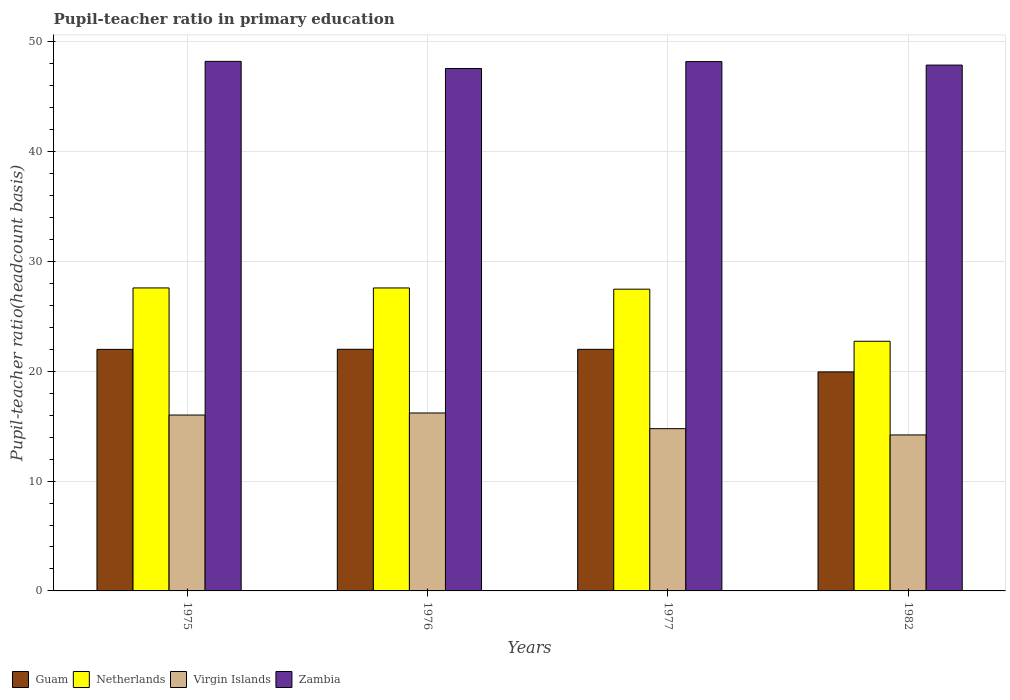How many different coloured bars are there?
Make the answer very short. 4. How many bars are there on the 1st tick from the left?
Keep it short and to the point. 4. In how many cases, is the number of bars for a given year not equal to the number of legend labels?
Your response must be concise. 0. What is the pupil-teacher ratio in primary education in Virgin Islands in 1976?
Ensure brevity in your answer.  16.2. Across all years, what is the maximum pupil-teacher ratio in primary education in Zambia?
Your response must be concise. 48.21. Across all years, what is the minimum pupil-teacher ratio in primary education in Zambia?
Your response must be concise. 47.56. In which year was the pupil-teacher ratio in primary education in Guam maximum?
Ensure brevity in your answer.  1976. What is the total pupil-teacher ratio in primary education in Zambia in the graph?
Ensure brevity in your answer.  191.83. What is the difference between the pupil-teacher ratio in primary education in Virgin Islands in 1975 and that in 1976?
Your answer should be compact. -0.19. What is the difference between the pupil-teacher ratio in primary education in Virgin Islands in 1982 and the pupil-teacher ratio in primary education in Netherlands in 1976?
Your answer should be compact. -13.38. What is the average pupil-teacher ratio in primary education in Virgin Islands per year?
Provide a succinct answer. 15.3. In the year 1975, what is the difference between the pupil-teacher ratio in primary education in Guam and pupil-teacher ratio in primary education in Netherlands?
Your answer should be very brief. -5.59. What is the ratio of the pupil-teacher ratio in primary education in Guam in 1975 to that in 1976?
Provide a short and direct response. 1. Is the difference between the pupil-teacher ratio in primary education in Guam in 1977 and 1982 greater than the difference between the pupil-teacher ratio in primary education in Netherlands in 1977 and 1982?
Make the answer very short. No. What is the difference between the highest and the second highest pupil-teacher ratio in primary education in Virgin Islands?
Keep it short and to the point. 0.19. What is the difference between the highest and the lowest pupil-teacher ratio in primary education in Netherlands?
Keep it short and to the point. 4.86. Is it the case that in every year, the sum of the pupil-teacher ratio in primary education in Netherlands and pupil-teacher ratio in primary education in Virgin Islands is greater than the sum of pupil-teacher ratio in primary education in Zambia and pupil-teacher ratio in primary education in Guam?
Provide a succinct answer. No. What does the 2nd bar from the right in 1977 represents?
Ensure brevity in your answer.  Virgin Islands. Is it the case that in every year, the sum of the pupil-teacher ratio in primary education in Guam and pupil-teacher ratio in primary education in Netherlands is greater than the pupil-teacher ratio in primary education in Virgin Islands?
Offer a very short reply. Yes. Are all the bars in the graph horizontal?
Offer a very short reply. No. How many years are there in the graph?
Keep it short and to the point. 4. What is the difference between two consecutive major ticks on the Y-axis?
Your answer should be compact. 10. Are the values on the major ticks of Y-axis written in scientific E-notation?
Your answer should be very brief. No. Does the graph contain grids?
Keep it short and to the point. Yes. How many legend labels are there?
Offer a very short reply. 4. How are the legend labels stacked?
Give a very brief answer. Horizontal. What is the title of the graph?
Your answer should be very brief. Pupil-teacher ratio in primary education. Does "Kazakhstan" appear as one of the legend labels in the graph?
Make the answer very short. No. What is the label or title of the X-axis?
Provide a succinct answer. Years. What is the label or title of the Y-axis?
Provide a succinct answer. Pupil-teacher ratio(headcount basis). What is the Pupil-teacher ratio(headcount basis) of Guam in 1975?
Your answer should be very brief. 21.99. What is the Pupil-teacher ratio(headcount basis) of Netherlands in 1975?
Keep it short and to the point. 27.58. What is the Pupil-teacher ratio(headcount basis) of Virgin Islands in 1975?
Provide a short and direct response. 16.01. What is the Pupil-teacher ratio(headcount basis) of Zambia in 1975?
Offer a terse response. 48.21. What is the Pupil-teacher ratio(headcount basis) of Guam in 1976?
Your answer should be compact. 22. What is the Pupil-teacher ratio(headcount basis) of Netherlands in 1976?
Your answer should be compact. 27.58. What is the Pupil-teacher ratio(headcount basis) of Virgin Islands in 1976?
Provide a short and direct response. 16.2. What is the Pupil-teacher ratio(headcount basis) in Zambia in 1976?
Offer a terse response. 47.56. What is the Pupil-teacher ratio(headcount basis) in Guam in 1977?
Your response must be concise. 21.99. What is the Pupil-teacher ratio(headcount basis) in Netherlands in 1977?
Provide a short and direct response. 27.47. What is the Pupil-teacher ratio(headcount basis) in Virgin Islands in 1977?
Your response must be concise. 14.77. What is the Pupil-teacher ratio(headcount basis) in Zambia in 1977?
Your answer should be compact. 48.19. What is the Pupil-teacher ratio(headcount basis) in Guam in 1982?
Make the answer very short. 19.94. What is the Pupil-teacher ratio(headcount basis) of Netherlands in 1982?
Provide a succinct answer. 22.73. What is the Pupil-teacher ratio(headcount basis) of Virgin Islands in 1982?
Give a very brief answer. 14.2. What is the Pupil-teacher ratio(headcount basis) in Zambia in 1982?
Ensure brevity in your answer.  47.87. Across all years, what is the maximum Pupil-teacher ratio(headcount basis) in Guam?
Keep it short and to the point. 22. Across all years, what is the maximum Pupil-teacher ratio(headcount basis) in Netherlands?
Ensure brevity in your answer.  27.58. Across all years, what is the maximum Pupil-teacher ratio(headcount basis) of Virgin Islands?
Make the answer very short. 16.2. Across all years, what is the maximum Pupil-teacher ratio(headcount basis) of Zambia?
Your response must be concise. 48.21. Across all years, what is the minimum Pupil-teacher ratio(headcount basis) of Guam?
Make the answer very short. 19.94. Across all years, what is the minimum Pupil-teacher ratio(headcount basis) in Netherlands?
Ensure brevity in your answer.  22.73. Across all years, what is the minimum Pupil-teacher ratio(headcount basis) in Zambia?
Keep it short and to the point. 47.56. What is the total Pupil-teacher ratio(headcount basis) of Guam in the graph?
Your answer should be very brief. 85.92. What is the total Pupil-teacher ratio(headcount basis) of Netherlands in the graph?
Offer a very short reply. 105.36. What is the total Pupil-teacher ratio(headcount basis) of Virgin Islands in the graph?
Provide a short and direct response. 61.18. What is the total Pupil-teacher ratio(headcount basis) of Zambia in the graph?
Provide a short and direct response. 191.83. What is the difference between the Pupil-teacher ratio(headcount basis) of Guam in 1975 and that in 1976?
Make the answer very short. -0.01. What is the difference between the Pupil-teacher ratio(headcount basis) in Netherlands in 1975 and that in 1976?
Offer a very short reply. 0. What is the difference between the Pupil-teacher ratio(headcount basis) in Virgin Islands in 1975 and that in 1976?
Offer a terse response. -0.19. What is the difference between the Pupil-teacher ratio(headcount basis) in Zambia in 1975 and that in 1976?
Keep it short and to the point. 0.65. What is the difference between the Pupil-teacher ratio(headcount basis) in Guam in 1975 and that in 1977?
Give a very brief answer. -0. What is the difference between the Pupil-teacher ratio(headcount basis) of Netherlands in 1975 and that in 1977?
Your answer should be very brief. 0.11. What is the difference between the Pupil-teacher ratio(headcount basis) of Virgin Islands in 1975 and that in 1977?
Make the answer very short. 1.24. What is the difference between the Pupil-teacher ratio(headcount basis) of Zambia in 1975 and that in 1977?
Your response must be concise. 0.02. What is the difference between the Pupil-teacher ratio(headcount basis) in Guam in 1975 and that in 1982?
Your response must be concise. 2.05. What is the difference between the Pupil-teacher ratio(headcount basis) in Netherlands in 1975 and that in 1982?
Offer a terse response. 4.86. What is the difference between the Pupil-teacher ratio(headcount basis) in Virgin Islands in 1975 and that in 1982?
Provide a succinct answer. 1.81. What is the difference between the Pupil-teacher ratio(headcount basis) in Zambia in 1975 and that in 1982?
Provide a succinct answer. 0.34. What is the difference between the Pupil-teacher ratio(headcount basis) of Guam in 1976 and that in 1977?
Your answer should be very brief. 0. What is the difference between the Pupil-teacher ratio(headcount basis) in Netherlands in 1976 and that in 1977?
Make the answer very short. 0.11. What is the difference between the Pupil-teacher ratio(headcount basis) of Virgin Islands in 1976 and that in 1977?
Offer a terse response. 1.43. What is the difference between the Pupil-teacher ratio(headcount basis) in Zambia in 1976 and that in 1977?
Ensure brevity in your answer.  -0.63. What is the difference between the Pupil-teacher ratio(headcount basis) of Guam in 1976 and that in 1982?
Your answer should be very brief. 2.06. What is the difference between the Pupil-teacher ratio(headcount basis) of Netherlands in 1976 and that in 1982?
Your answer should be very brief. 4.85. What is the difference between the Pupil-teacher ratio(headcount basis) of Virgin Islands in 1976 and that in 1982?
Your answer should be very brief. 2. What is the difference between the Pupil-teacher ratio(headcount basis) in Zambia in 1976 and that in 1982?
Your response must be concise. -0.31. What is the difference between the Pupil-teacher ratio(headcount basis) in Guam in 1977 and that in 1982?
Offer a terse response. 2.05. What is the difference between the Pupil-teacher ratio(headcount basis) of Netherlands in 1977 and that in 1982?
Give a very brief answer. 4.74. What is the difference between the Pupil-teacher ratio(headcount basis) in Virgin Islands in 1977 and that in 1982?
Make the answer very short. 0.57. What is the difference between the Pupil-teacher ratio(headcount basis) in Zambia in 1977 and that in 1982?
Offer a very short reply. 0.32. What is the difference between the Pupil-teacher ratio(headcount basis) in Guam in 1975 and the Pupil-teacher ratio(headcount basis) in Netherlands in 1976?
Offer a very short reply. -5.59. What is the difference between the Pupil-teacher ratio(headcount basis) in Guam in 1975 and the Pupil-teacher ratio(headcount basis) in Virgin Islands in 1976?
Give a very brief answer. 5.79. What is the difference between the Pupil-teacher ratio(headcount basis) of Guam in 1975 and the Pupil-teacher ratio(headcount basis) of Zambia in 1976?
Your answer should be very brief. -25.57. What is the difference between the Pupil-teacher ratio(headcount basis) in Netherlands in 1975 and the Pupil-teacher ratio(headcount basis) in Virgin Islands in 1976?
Your answer should be compact. 11.38. What is the difference between the Pupil-teacher ratio(headcount basis) of Netherlands in 1975 and the Pupil-teacher ratio(headcount basis) of Zambia in 1976?
Ensure brevity in your answer.  -19.98. What is the difference between the Pupil-teacher ratio(headcount basis) in Virgin Islands in 1975 and the Pupil-teacher ratio(headcount basis) in Zambia in 1976?
Provide a short and direct response. -31.55. What is the difference between the Pupil-teacher ratio(headcount basis) in Guam in 1975 and the Pupil-teacher ratio(headcount basis) in Netherlands in 1977?
Offer a terse response. -5.48. What is the difference between the Pupil-teacher ratio(headcount basis) in Guam in 1975 and the Pupil-teacher ratio(headcount basis) in Virgin Islands in 1977?
Provide a short and direct response. 7.22. What is the difference between the Pupil-teacher ratio(headcount basis) in Guam in 1975 and the Pupil-teacher ratio(headcount basis) in Zambia in 1977?
Offer a terse response. -26.2. What is the difference between the Pupil-teacher ratio(headcount basis) of Netherlands in 1975 and the Pupil-teacher ratio(headcount basis) of Virgin Islands in 1977?
Provide a short and direct response. 12.81. What is the difference between the Pupil-teacher ratio(headcount basis) of Netherlands in 1975 and the Pupil-teacher ratio(headcount basis) of Zambia in 1977?
Your answer should be very brief. -20.61. What is the difference between the Pupil-teacher ratio(headcount basis) of Virgin Islands in 1975 and the Pupil-teacher ratio(headcount basis) of Zambia in 1977?
Ensure brevity in your answer.  -32.18. What is the difference between the Pupil-teacher ratio(headcount basis) in Guam in 1975 and the Pupil-teacher ratio(headcount basis) in Netherlands in 1982?
Give a very brief answer. -0.74. What is the difference between the Pupil-teacher ratio(headcount basis) of Guam in 1975 and the Pupil-teacher ratio(headcount basis) of Virgin Islands in 1982?
Provide a short and direct response. 7.79. What is the difference between the Pupil-teacher ratio(headcount basis) of Guam in 1975 and the Pupil-teacher ratio(headcount basis) of Zambia in 1982?
Your response must be concise. -25.88. What is the difference between the Pupil-teacher ratio(headcount basis) of Netherlands in 1975 and the Pupil-teacher ratio(headcount basis) of Virgin Islands in 1982?
Give a very brief answer. 13.38. What is the difference between the Pupil-teacher ratio(headcount basis) of Netherlands in 1975 and the Pupil-teacher ratio(headcount basis) of Zambia in 1982?
Give a very brief answer. -20.29. What is the difference between the Pupil-teacher ratio(headcount basis) of Virgin Islands in 1975 and the Pupil-teacher ratio(headcount basis) of Zambia in 1982?
Keep it short and to the point. -31.86. What is the difference between the Pupil-teacher ratio(headcount basis) in Guam in 1976 and the Pupil-teacher ratio(headcount basis) in Netherlands in 1977?
Your answer should be compact. -5.47. What is the difference between the Pupil-teacher ratio(headcount basis) of Guam in 1976 and the Pupil-teacher ratio(headcount basis) of Virgin Islands in 1977?
Provide a succinct answer. 7.22. What is the difference between the Pupil-teacher ratio(headcount basis) of Guam in 1976 and the Pupil-teacher ratio(headcount basis) of Zambia in 1977?
Your answer should be very brief. -26.19. What is the difference between the Pupil-teacher ratio(headcount basis) in Netherlands in 1976 and the Pupil-teacher ratio(headcount basis) in Virgin Islands in 1977?
Your answer should be very brief. 12.81. What is the difference between the Pupil-teacher ratio(headcount basis) in Netherlands in 1976 and the Pupil-teacher ratio(headcount basis) in Zambia in 1977?
Give a very brief answer. -20.61. What is the difference between the Pupil-teacher ratio(headcount basis) in Virgin Islands in 1976 and the Pupil-teacher ratio(headcount basis) in Zambia in 1977?
Offer a terse response. -31.99. What is the difference between the Pupil-teacher ratio(headcount basis) of Guam in 1976 and the Pupil-teacher ratio(headcount basis) of Netherlands in 1982?
Your answer should be very brief. -0.73. What is the difference between the Pupil-teacher ratio(headcount basis) of Guam in 1976 and the Pupil-teacher ratio(headcount basis) of Virgin Islands in 1982?
Ensure brevity in your answer.  7.8. What is the difference between the Pupil-teacher ratio(headcount basis) of Guam in 1976 and the Pupil-teacher ratio(headcount basis) of Zambia in 1982?
Ensure brevity in your answer.  -25.87. What is the difference between the Pupil-teacher ratio(headcount basis) of Netherlands in 1976 and the Pupil-teacher ratio(headcount basis) of Virgin Islands in 1982?
Ensure brevity in your answer.  13.38. What is the difference between the Pupil-teacher ratio(headcount basis) in Netherlands in 1976 and the Pupil-teacher ratio(headcount basis) in Zambia in 1982?
Make the answer very short. -20.29. What is the difference between the Pupil-teacher ratio(headcount basis) in Virgin Islands in 1976 and the Pupil-teacher ratio(headcount basis) in Zambia in 1982?
Provide a short and direct response. -31.67. What is the difference between the Pupil-teacher ratio(headcount basis) in Guam in 1977 and the Pupil-teacher ratio(headcount basis) in Netherlands in 1982?
Make the answer very short. -0.73. What is the difference between the Pupil-teacher ratio(headcount basis) of Guam in 1977 and the Pupil-teacher ratio(headcount basis) of Virgin Islands in 1982?
Keep it short and to the point. 7.79. What is the difference between the Pupil-teacher ratio(headcount basis) of Guam in 1977 and the Pupil-teacher ratio(headcount basis) of Zambia in 1982?
Make the answer very short. -25.88. What is the difference between the Pupil-teacher ratio(headcount basis) of Netherlands in 1977 and the Pupil-teacher ratio(headcount basis) of Virgin Islands in 1982?
Keep it short and to the point. 13.27. What is the difference between the Pupil-teacher ratio(headcount basis) of Netherlands in 1977 and the Pupil-teacher ratio(headcount basis) of Zambia in 1982?
Your response must be concise. -20.4. What is the difference between the Pupil-teacher ratio(headcount basis) in Virgin Islands in 1977 and the Pupil-teacher ratio(headcount basis) in Zambia in 1982?
Your answer should be very brief. -33.1. What is the average Pupil-teacher ratio(headcount basis) in Guam per year?
Give a very brief answer. 21.48. What is the average Pupil-teacher ratio(headcount basis) of Netherlands per year?
Provide a succinct answer. 26.34. What is the average Pupil-teacher ratio(headcount basis) of Virgin Islands per year?
Provide a short and direct response. 15.3. What is the average Pupil-teacher ratio(headcount basis) in Zambia per year?
Your answer should be very brief. 47.96. In the year 1975, what is the difference between the Pupil-teacher ratio(headcount basis) in Guam and Pupil-teacher ratio(headcount basis) in Netherlands?
Your answer should be very brief. -5.59. In the year 1975, what is the difference between the Pupil-teacher ratio(headcount basis) in Guam and Pupil-teacher ratio(headcount basis) in Virgin Islands?
Offer a very short reply. 5.98. In the year 1975, what is the difference between the Pupil-teacher ratio(headcount basis) of Guam and Pupil-teacher ratio(headcount basis) of Zambia?
Provide a succinct answer. -26.22. In the year 1975, what is the difference between the Pupil-teacher ratio(headcount basis) of Netherlands and Pupil-teacher ratio(headcount basis) of Virgin Islands?
Provide a short and direct response. 11.57. In the year 1975, what is the difference between the Pupil-teacher ratio(headcount basis) of Netherlands and Pupil-teacher ratio(headcount basis) of Zambia?
Your response must be concise. -20.63. In the year 1975, what is the difference between the Pupil-teacher ratio(headcount basis) in Virgin Islands and Pupil-teacher ratio(headcount basis) in Zambia?
Provide a succinct answer. -32.2. In the year 1976, what is the difference between the Pupil-teacher ratio(headcount basis) of Guam and Pupil-teacher ratio(headcount basis) of Netherlands?
Ensure brevity in your answer.  -5.58. In the year 1976, what is the difference between the Pupil-teacher ratio(headcount basis) in Guam and Pupil-teacher ratio(headcount basis) in Virgin Islands?
Your answer should be compact. 5.8. In the year 1976, what is the difference between the Pupil-teacher ratio(headcount basis) in Guam and Pupil-teacher ratio(headcount basis) in Zambia?
Your answer should be very brief. -25.56. In the year 1976, what is the difference between the Pupil-teacher ratio(headcount basis) in Netherlands and Pupil-teacher ratio(headcount basis) in Virgin Islands?
Provide a short and direct response. 11.38. In the year 1976, what is the difference between the Pupil-teacher ratio(headcount basis) in Netherlands and Pupil-teacher ratio(headcount basis) in Zambia?
Offer a terse response. -19.98. In the year 1976, what is the difference between the Pupil-teacher ratio(headcount basis) in Virgin Islands and Pupil-teacher ratio(headcount basis) in Zambia?
Provide a short and direct response. -31.36. In the year 1977, what is the difference between the Pupil-teacher ratio(headcount basis) in Guam and Pupil-teacher ratio(headcount basis) in Netherlands?
Give a very brief answer. -5.48. In the year 1977, what is the difference between the Pupil-teacher ratio(headcount basis) in Guam and Pupil-teacher ratio(headcount basis) in Virgin Islands?
Your response must be concise. 7.22. In the year 1977, what is the difference between the Pupil-teacher ratio(headcount basis) of Guam and Pupil-teacher ratio(headcount basis) of Zambia?
Offer a very short reply. -26.2. In the year 1977, what is the difference between the Pupil-teacher ratio(headcount basis) of Netherlands and Pupil-teacher ratio(headcount basis) of Virgin Islands?
Ensure brevity in your answer.  12.7. In the year 1977, what is the difference between the Pupil-teacher ratio(headcount basis) of Netherlands and Pupil-teacher ratio(headcount basis) of Zambia?
Give a very brief answer. -20.72. In the year 1977, what is the difference between the Pupil-teacher ratio(headcount basis) of Virgin Islands and Pupil-teacher ratio(headcount basis) of Zambia?
Your answer should be very brief. -33.42. In the year 1982, what is the difference between the Pupil-teacher ratio(headcount basis) in Guam and Pupil-teacher ratio(headcount basis) in Netherlands?
Make the answer very short. -2.79. In the year 1982, what is the difference between the Pupil-teacher ratio(headcount basis) of Guam and Pupil-teacher ratio(headcount basis) of Virgin Islands?
Your answer should be very brief. 5.74. In the year 1982, what is the difference between the Pupil-teacher ratio(headcount basis) in Guam and Pupil-teacher ratio(headcount basis) in Zambia?
Offer a terse response. -27.93. In the year 1982, what is the difference between the Pupil-teacher ratio(headcount basis) of Netherlands and Pupil-teacher ratio(headcount basis) of Virgin Islands?
Offer a terse response. 8.53. In the year 1982, what is the difference between the Pupil-teacher ratio(headcount basis) in Netherlands and Pupil-teacher ratio(headcount basis) in Zambia?
Offer a terse response. -25.14. In the year 1982, what is the difference between the Pupil-teacher ratio(headcount basis) in Virgin Islands and Pupil-teacher ratio(headcount basis) in Zambia?
Offer a very short reply. -33.67. What is the ratio of the Pupil-teacher ratio(headcount basis) of Guam in 1975 to that in 1976?
Your response must be concise. 1. What is the ratio of the Pupil-teacher ratio(headcount basis) of Netherlands in 1975 to that in 1976?
Your answer should be very brief. 1. What is the ratio of the Pupil-teacher ratio(headcount basis) in Virgin Islands in 1975 to that in 1976?
Give a very brief answer. 0.99. What is the ratio of the Pupil-teacher ratio(headcount basis) in Zambia in 1975 to that in 1976?
Ensure brevity in your answer.  1.01. What is the ratio of the Pupil-teacher ratio(headcount basis) of Virgin Islands in 1975 to that in 1977?
Offer a very short reply. 1.08. What is the ratio of the Pupil-teacher ratio(headcount basis) in Guam in 1975 to that in 1982?
Provide a succinct answer. 1.1. What is the ratio of the Pupil-teacher ratio(headcount basis) of Netherlands in 1975 to that in 1982?
Your answer should be very brief. 1.21. What is the ratio of the Pupil-teacher ratio(headcount basis) in Virgin Islands in 1975 to that in 1982?
Ensure brevity in your answer.  1.13. What is the ratio of the Pupil-teacher ratio(headcount basis) of Zambia in 1975 to that in 1982?
Make the answer very short. 1.01. What is the ratio of the Pupil-teacher ratio(headcount basis) of Guam in 1976 to that in 1977?
Provide a succinct answer. 1. What is the ratio of the Pupil-teacher ratio(headcount basis) in Netherlands in 1976 to that in 1977?
Keep it short and to the point. 1. What is the ratio of the Pupil-teacher ratio(headcount basis) in Virgin Islands in 1976 to that in 1977?
Ensure brevity in your answer.  1.1. What is the ratio of the Pupil-teacher ratio(headcount basis) of Guam in 1976 to that in 1982?
Your answer should be compact. 1.1. What is the ratio of the Pupil-teacher ratio(headcount basis) of Netherlands in 1976 to that in 1982?
Provide a short and direct response. 1.21. What is the ratio of the Pupil-teacher ratio(headcount basis) in Virgin Islands in 1976 to that in 1982?
Make the answer very short. 1.14. What is the ratio of the Pupil-teacher ratio(headcount basis) in Zambia in 1976 to that in 1982?
Ensure brevity in your answer.  0.99. What is the ratio of the Pupil-teacher ratio(headcount basis) of Guam in 1977 to that in 1982?
Ensure brevity in your answer.  1.1. What is the ratio of the Pupil-teacher ratio(headcount basis) of Netherlands in 1977 to that in 1982?
Offer a terse response. 1.21. What is the ratio of the Pupil-teacher ratio(headcount basis) in Virgin Islands in 1977 to that in 1982?
Your answer should be very brief. 1.04. What is the ratio of the Pupil-teacher ratio(headcount basis) in Zambia in 1977 to that in 1982?
Ensure brevity in your answer.  1.01. What is the difference between the highest and the second highest Pupil-teacher ratio(headcount basis) of Guam?
Your answer should be very brief. 0. What is the difference between the highest and the second highest Pupil-teacher ratio(headcount basis) of Netherlands?
Your answer should be compact. 0. What is the difference between the highest and the second highest Pupil-teacher ratio(headcount basis) of Virgin Islands?
Ensure brevity in your answer.  0.19. What is the difference between the highest and the second highest Pupil-teacher ratio(headcount basis) in Zambia?
Offer a very short reply. 0.02. What is the difference between the highest and the lowest Pupil-teacher ratio(headcount basis) of Guam?
Keep it short and to the point. 2.06. What is the difference between the highest and the lowest Pupil-teacher ratio(headcount basis) of Netherlands?
Provide a short and direct response. 4.86. What is the difference between the highest and the lowest Pupil-teacher ratio(headcount basis) in Virgin Islands?
Give a very brief answer. 2. What is the difference between the highest and the lowest Pupil-teacher ratio(headcount basis) in Zambia?
Your answer should be compact. 0.65. 